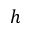<formula> <loc_0><loc_0><loc_500><loc_500>h</formula> 